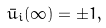<formula> <loc_0><loc_0><loc_500><loc_500>\bar { u } _ { i } ( \infty ) = \pm 1 ,</formula> 